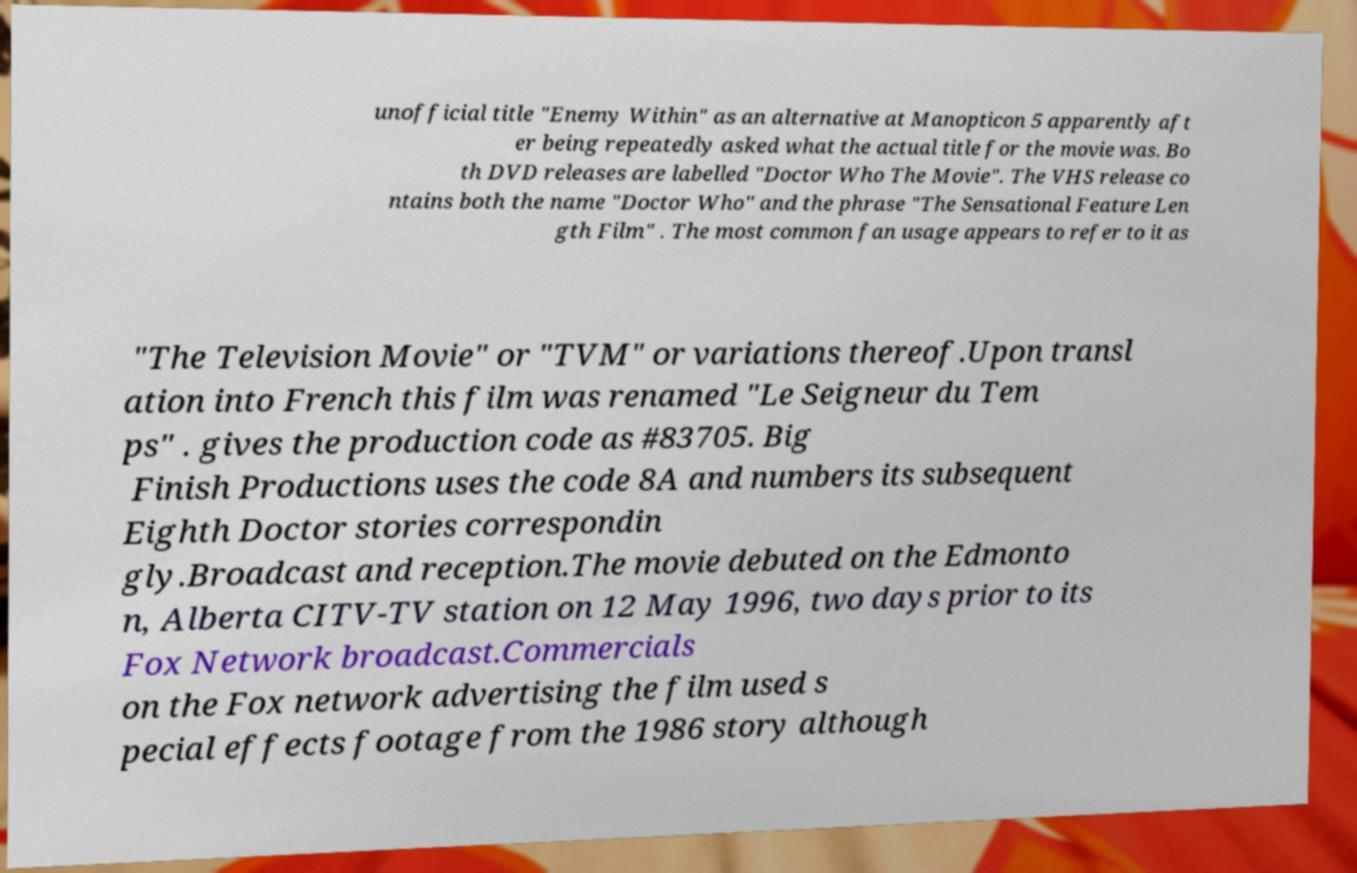Could you assist in decoding the text presented in this image and type it out clearly? unofficial title "Enemy Within" as an alternative at Manopticon 5 apparently aft er being repeatedly asked what the actual title for the movie was. Bo th DVD releases are labelled "Doctor Who The Movie". The VHS release co ntains both the name "Doctor Who" and the phrase "The Sensational Feature Len gth Film" . The most common fan usage appears to refer to it as "The Television Movie" or "TVM" or variations thereof.Upon transl ation into French this film was renamed "Le Seigneur du Tem ps" . gives the production code as #83705. Big Finish Productions uses the code 8A and numbers its subsequent Eighth Doctor stories correspondin gly.Broadcast and reception.The movie debuted on the Edmonto n, Alberta CITV-TV station on 12 May 1996, two days prior to its Fox Network broadcast.Commercials on the Fox network advertising the film used s pecial effects footage from the 1986 story although 